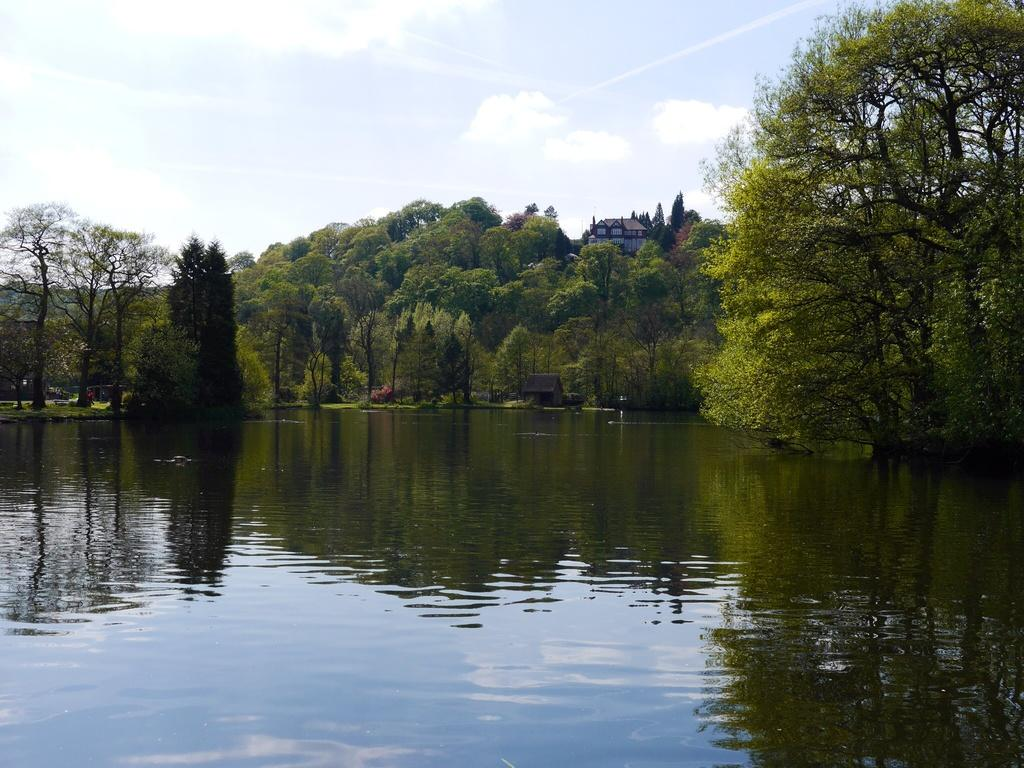What is one of the natural elements present in the image? There is water in the image. What type of vegetation can be seen in the image? There are trees and grass in the image. What type of structures are visible? There are houses in the image. What geographical feature can be seen in the distance? There are mountains in the image. What part of the natural environment is visible in the image? The sky is visible in the image. What might be the location of the image, based on the presence of water? The image may have been taken near a lake, as there is a significant amount of water present. What type of wine can be seen growing on the trees in the image? There is no wine present in the image, and trees in the image are not associated with wine growth. 